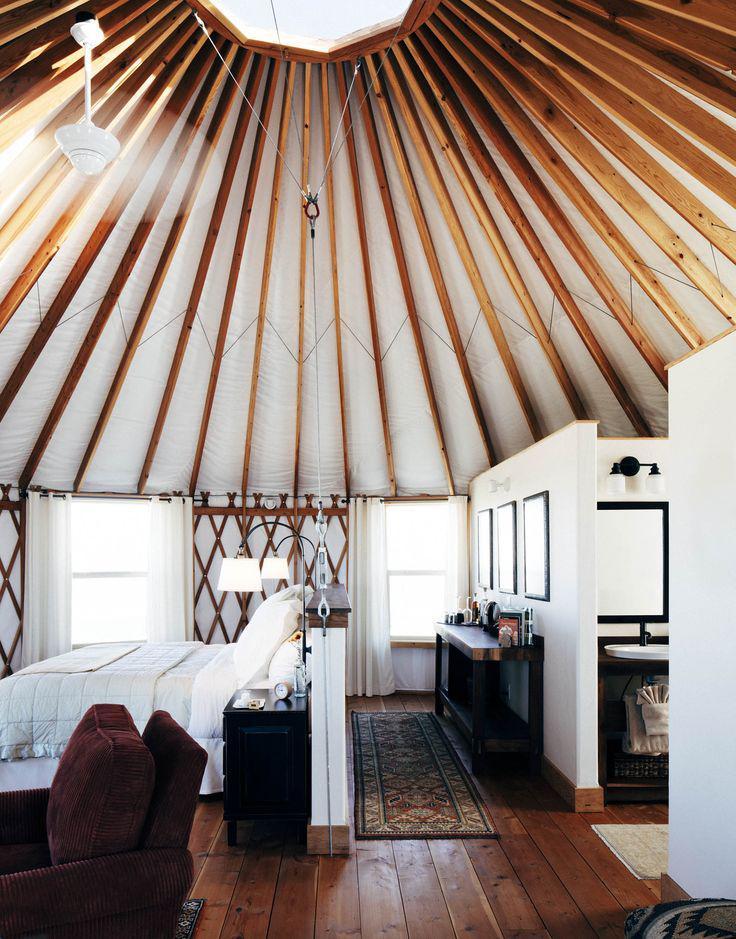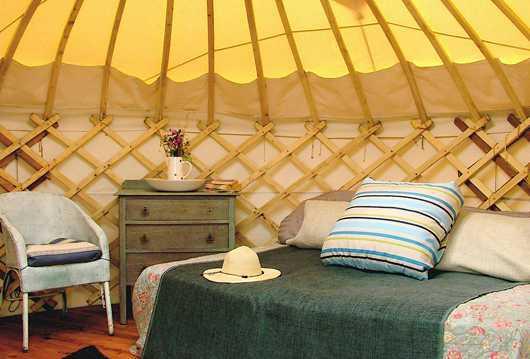The first image is the image on the left, the second image is the image on the right. Assess this claim about the two images: "There is one striped pillow in the image on the right.". Correct or not? Answer yes or no. Yes. 